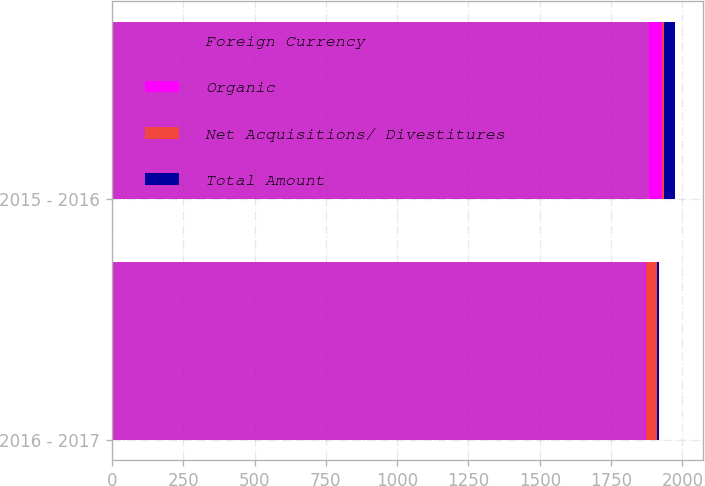Convert chart to OTSL. <chart><loc_0><loc_0><loc_500><loc_500><stacked_bar_chart><ecel><fcel>2016 - 2017<fcel>2015 - 2016<nl><fcel>Foreign Currency<fcel>1870.5<fcel>1884.2<nl><fcel>Organic<fcel>2.5<fcel>43.6<nl><fcel>Net Acquisitions/ Divestitures<fcel>36.7<fcel>8.7<nl><fcel>Total Amount<fcel>9.4<fcel>38.6<nl></chart> 